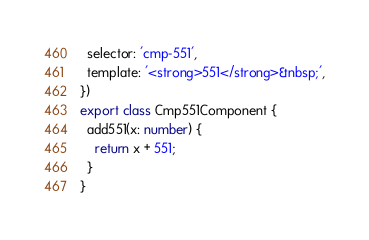<code> <loc_0><loc_0><loc_500><loc_500><_TypeScript_>  selector: 'cmp-551',
  template: '<strong>551</strong>&nbsp;',
})
export class Cmp551Component {
  add551(x: number) {
    return x + 551;
  }
}</code> 